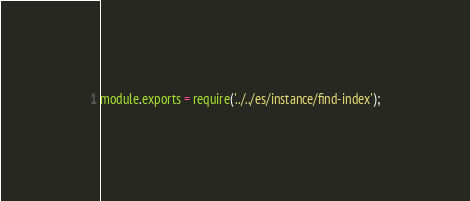<code> <loc_0><loc_0><loc_500><loc_500><_JavaScript_>module.exports = require('../../es/instance/find-index');
</code> 